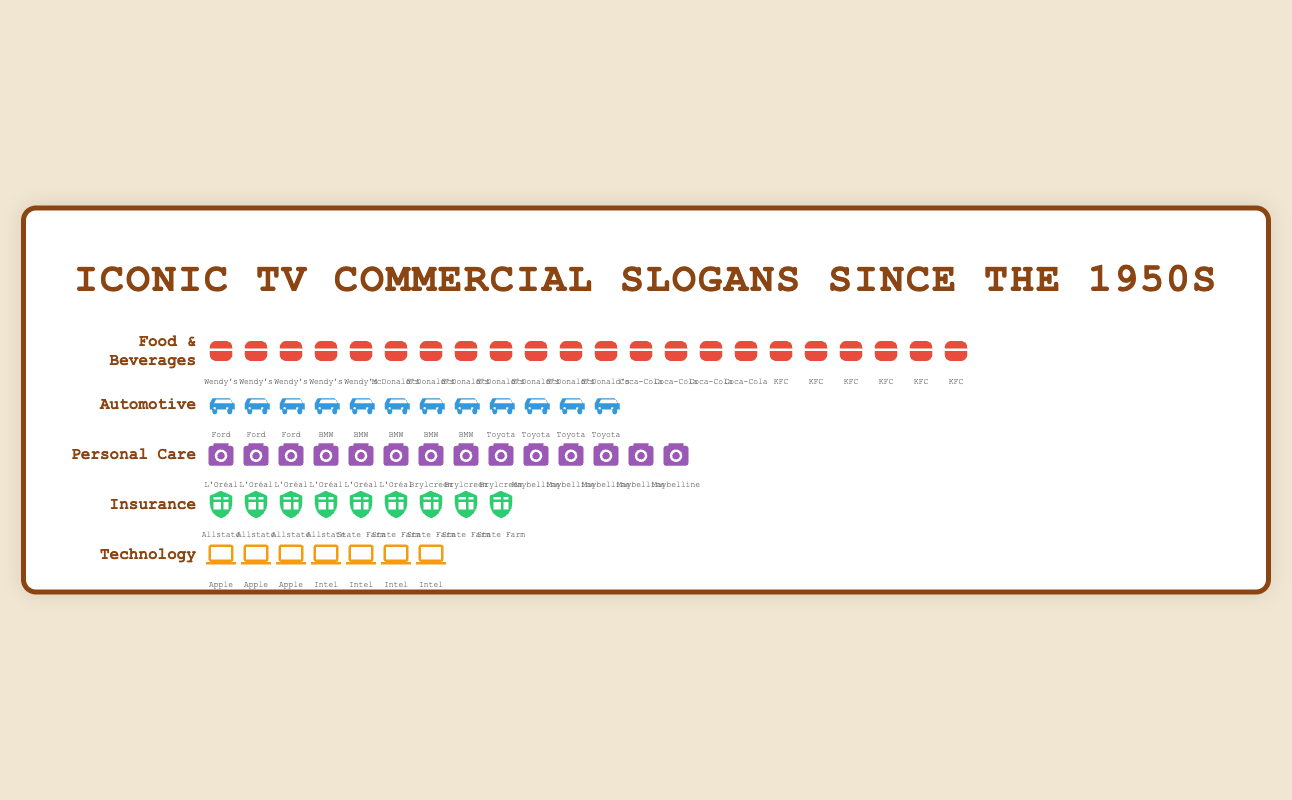What is the most frequently appearing slogan in the Food & Beverages category? Count the number of icons for each slogan within the Food & Beverages category. "I'm lovin' it" by McDonald's has the highest count with 7 icons.
Answer: "I'm lovin' it" Which product category has the fewest total slogans? Calculate the number of total slogans in each category. The Technology category has the fewest total slogans with 7.
Answer: Technology How many times does the slogan "Because you're worth it" from L'Oréal appear? Count the number of icons labeled with "L'Oréal" in the Personal Care category. There are 6 icons corresponding to the L'Oréal slogan.
Answer: 6 Compare the number of slogans between McDonald's and KFC. Which one has more? Count the icons labeled "McDonald's" and "KFC" in the Food & Beverages category. McDonald's has 7 iconic slogans, whereas KFC has 6.
Answer: McDonald’s What is the total count of slogans in the Insurance category? Add up the number of icons for each slogan in the Insurance category. "You're in good hands" has 4, and "Like a good neighbor" has 5. Summing these gives 4 + 5 = 9.
Answer: 9 Which Automotive brand has the most iconic slogans, and how many? Count the icons for each brand in the Automotive category. BMW has the most with 5, Same as the total number from Toyota.
Answer: BMW and Toyota (both with 5) How often does the slogan "Intel Inside" appear in the Technology category? Count the number of icons labeled "Intel" in the Technology category. There are 4 icons.
Answer: 4 What is the combined total of slogans for "Wendy's" and "Brylcreem"? Count the icons for "Wendy's" in the Food & Beverages category (5) and for "Brylcreem" in the Personal Care category (3). Summing these gives 5 + 3 = 8.
Answer: 8 Which category has the highest number of iconic slogans, and how many does it have? Count the total number of icons in each category. The Food & Beverages category has the most, with a total of 22 icons.
Answer: Food & Beverages, 22 What is the combined number of slogans in the Personal Care and Automotive categories? Add the individual counts for slogans in the Personal Care and Automotive categories. Personal Care has 14 slogans, and Automotive has 12 slogans. Therefore, the combined number is 14 + 12 = 26.
Answer: 26 